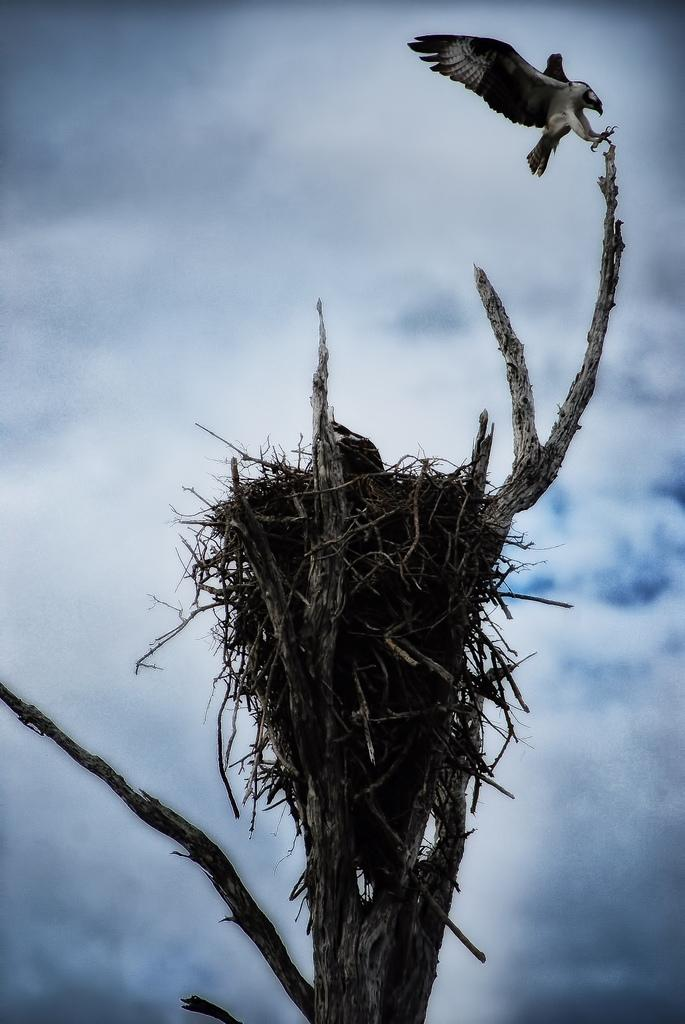What is located on the tree in the image? There is a nest on a tree in the image. Can you describe the bird in the image? There is a bird in the image. How would you describe the sky in the image? The sky is cloudy in the image. What type of show is the bird performing in the image? There is no show or performance depicted in the image; it simply shows a bird in a nest on a tree. Can you recall any memories the bird might have in the image? The image does not provide any information about the bird's memories, as it only shows the bird in its natural environment. 